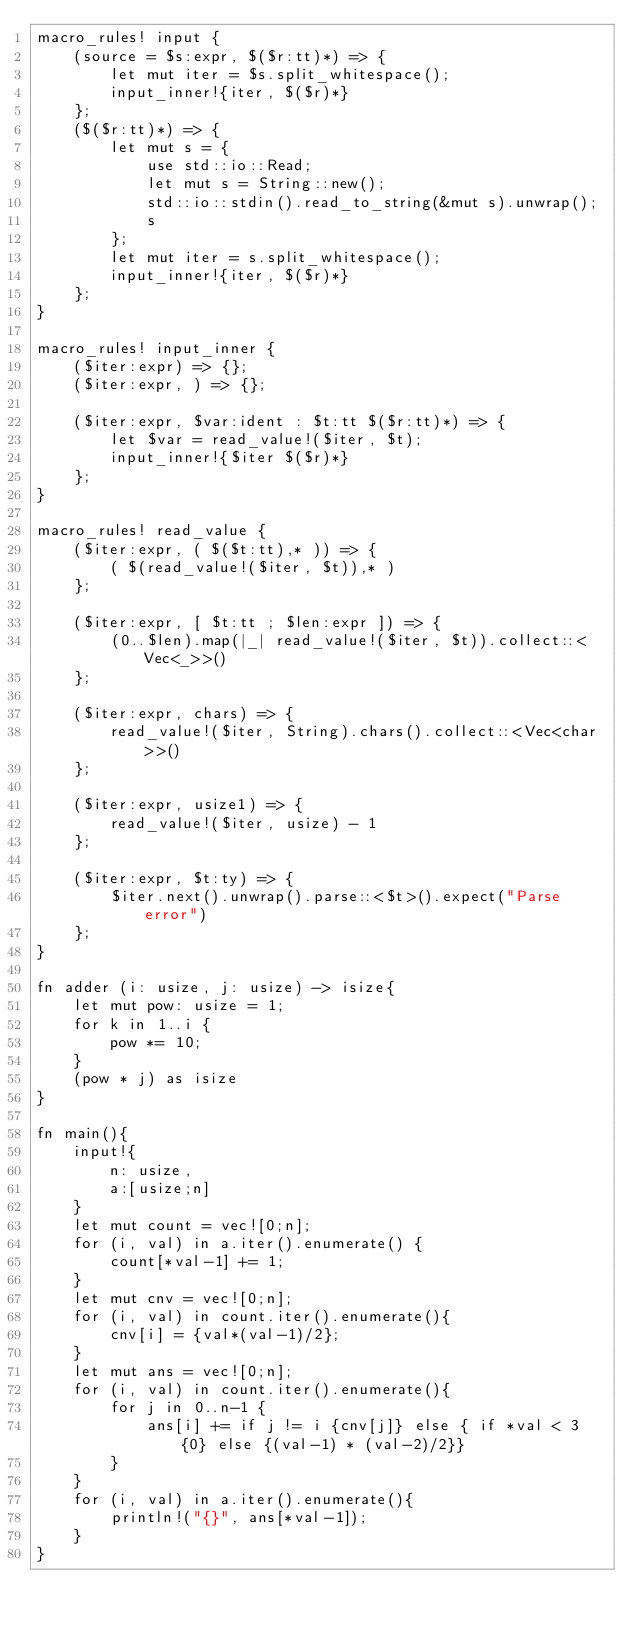<code> <loc_0><loc_0><loc_500><loc_500><_Rust_>macro_rules! input {
    (source = $s:expr, $($r:tt)*) => {
        let mut iter = $s.split_whitespace();
        input_inner!{iter, $($r)*}
    };
    ($($r:tt)*) => {
        let mut s = {
            use std::io::Read;
            let mut s = String::new();
            std::io::stdin().read_to_string(&mut s).unwrap();
            s
        };
        let mut iter = s.split_whitespace();
        input_inner!{iter, $($r)*}
    };
}

macro_rules! input_inner {
    ($iter:expr) => {};
    ($iter:expr, ) => {};

    ($iter:expr, $var:ident : $t:tt $($r:tt)*) => {
        let $var = read_value!($iter, $t);
        input_inner!{$iter $($r)*}
    };
}

macro_rules! read_value {
    ($iter:expr, ( $($t:tt),* )) => {
        ( $(read_value!($iter, $t)),* )
    };

    ($iter:expr, [ $t:tt ; $len:expr ]) => {
        (0..$len).map(|_| read_value!($iter, $t)).collect::<Vec<_>>()
    };

    ($iter:expr, chars) => {
        read_value!($iter, String).chars().collect::<Vec<char>>()
    };

    ($iter:expr, usize1) => {
        read_value!($iter, usize) - 1
    };

    ($iter:expr, $t:ty) => {
        $iter.next().unwrap().parse::<$t>().expect("Parse error")
    };
}

fn adder (i: usize, j: usize) -> isize{
    let mut pow: usize = 1;
    for k in 1..i {
        pow *= 10;
    }
    (pow * j) as isize
}

fn main(){
    input!{
        n: usize,
        a:[usize;n]
    }
    let mut count = vec![0;n];
    for (i, val) in a.iter().enumerate() {
        count[*val-1] += 1;
    }
    let mut cnv = vec![0;n];
    for (i, val) in count.iter().enumerate(){
        cnv[i] = {val*(val-1)/2};
    }
    let mut ans = vec![0;n];
    for (i, val) in count.iter().enumerate(){
        for j in 0..n-1 {
            ans[i] += if j != i {cnv[j]} else { if *val < 3 {0} else {(val-1) * (val-2)/2}}
        }
    }
    for (i, val) in a.iter().enumerate(){
        println!("{}", ans[*val-1]);
    }
}
</code> 